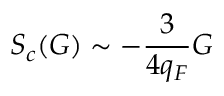Convert formula to latex. <formula><loc_0><loc_0><loc_500><loc_500>S _ { c } ( G ) \sim - \frac { 3 } { 4 q _ { F } } G</formula> 